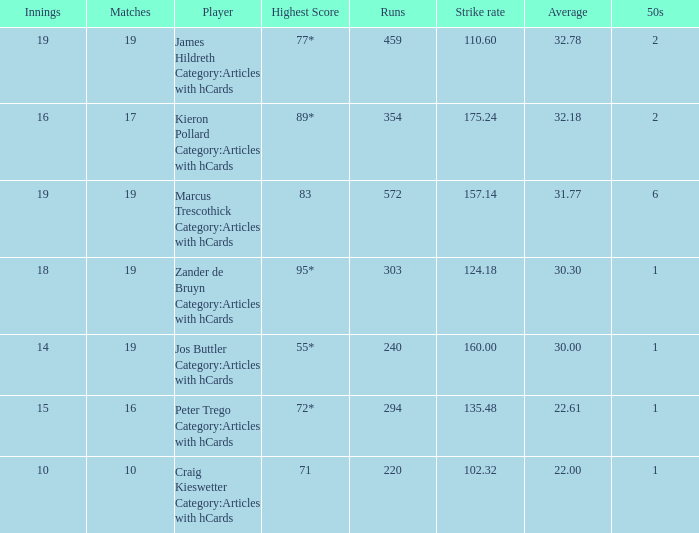What is the strike rate for the player with an average of 32.78? 110.6. 